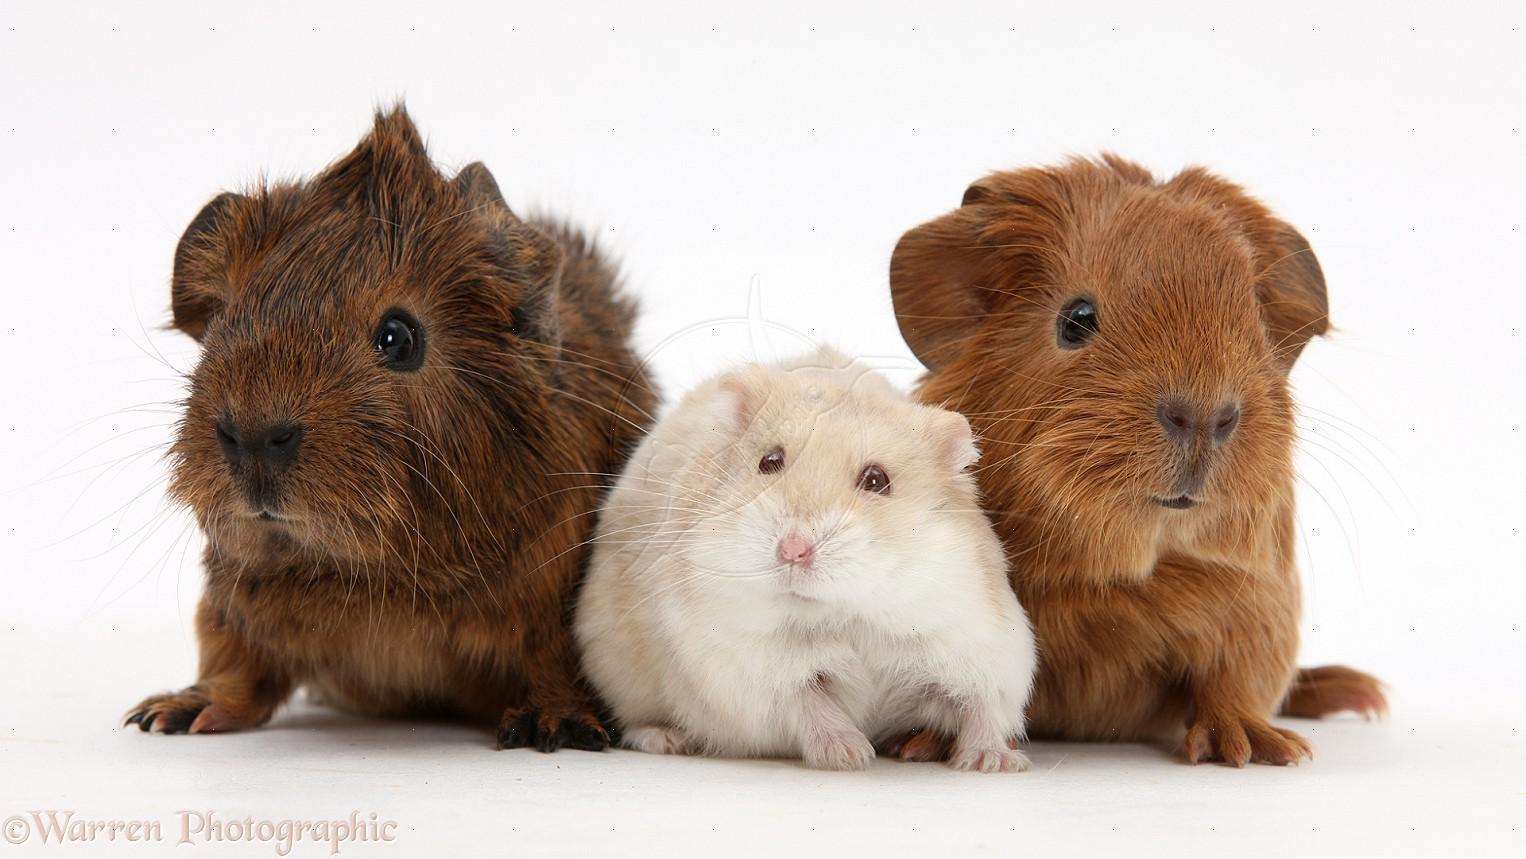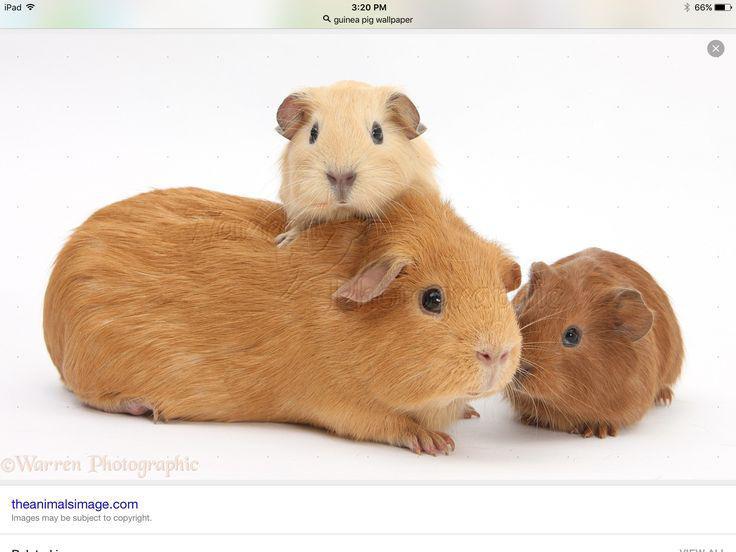The first image is the image on the left, the second image is the image on the right. Evaluate the accuracy of this statement regarding the images: "Two rodents are posing side by side.". Is it true? Answer yes or no. No. The first image is the image on the left, the second image is the image on the right. Assess this claim about the two images: "An image features a larger rodent with at least one smaller rodent's head on its back.". Correct or not? Answer yes or no. Yes. 